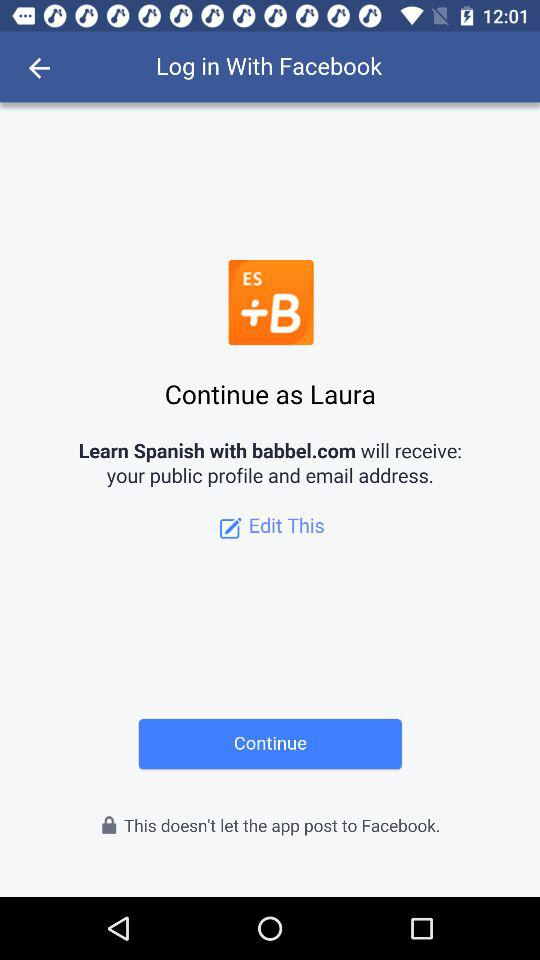What is the application name? The application name is "Learn Spanish with babbel.com". 